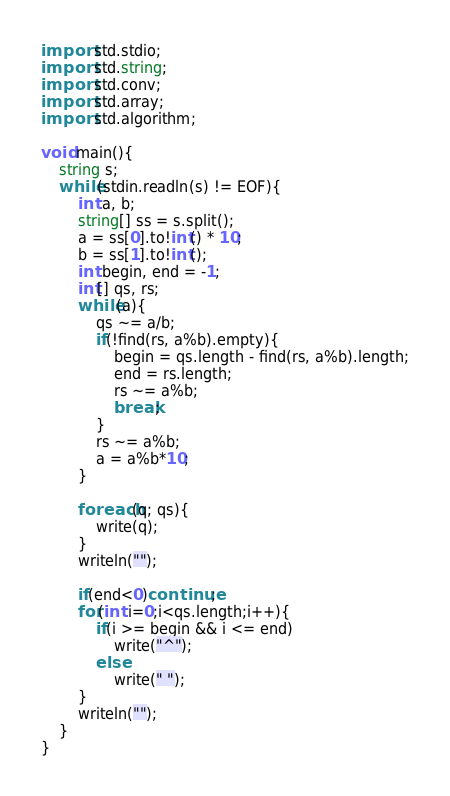<code> <loc_0><loc_0><loc_500><loc_500><_D_>import std.stdio;
import std.string;
import std.conv;
import std.array;
import std.algorithm;

void main(){
	string s;
	while(stdin.readln(s) != EOF){
		int a, b;
		string[] ss = s.split();
		a = ss[0].to!int() * 10;
		b = ss[1].to!int();
		int begin, end = -1;
		int[] qs, rs;
		while(a){
			qs ~= a/b;
			if(!find(rs, a%b).empty){
				begin = qs.length - find(rs, a%b).length;
				end = rs.length;
				rs ~= a%b;
				break;
			}
			rs ~= a%b;
			a = a%b*10;
		}
		
		foreach(q; qs){
			write(q);
		}
		writeln("");
		
		if(end<0)continue;
		for(int i=0;i<qs.length;i++){
			if(i >= begin && i <= end)
				write("^");
			else
				write(" ");
		}
		writeln("");
	}
}</code> 